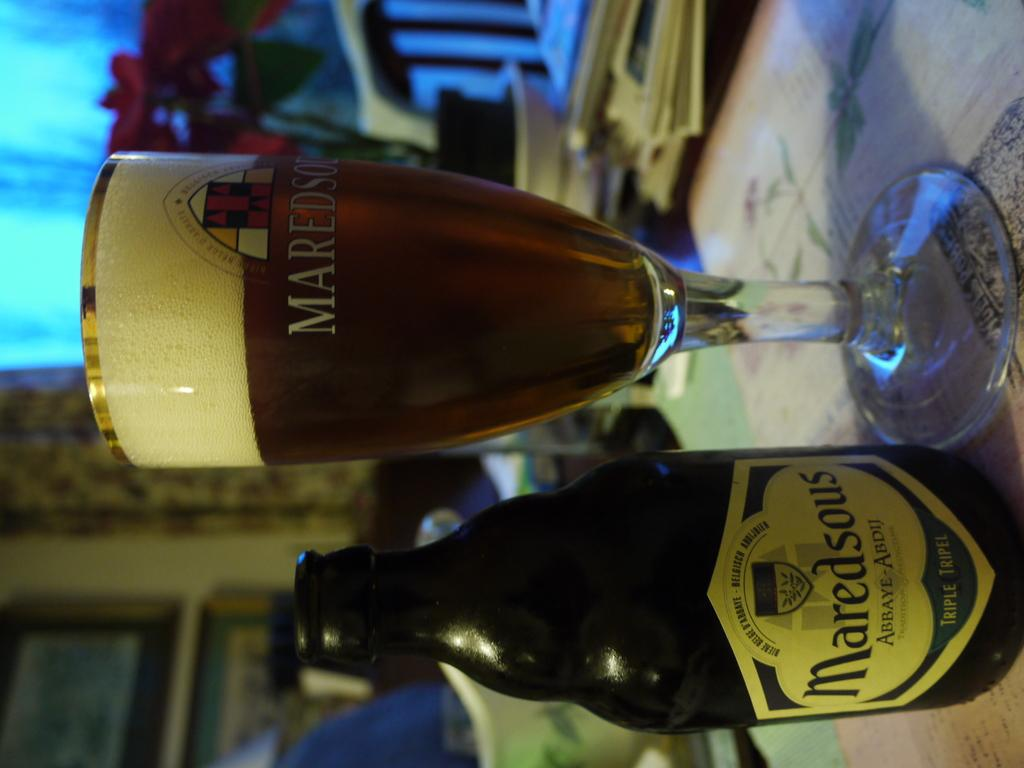Provide a one-sentence caption for the provided image. A refreshing Maredsous beverage awaits you on the table. 